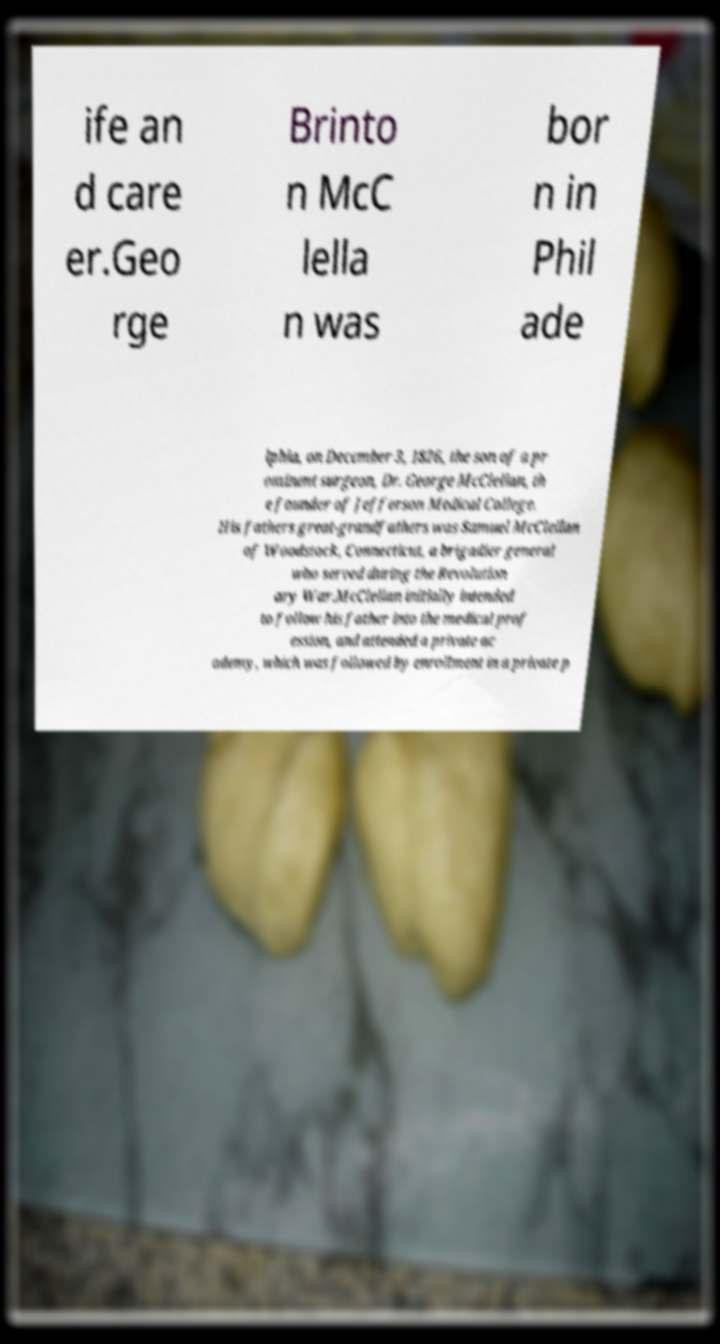For documentation purposes, I need the text within this image transcribed. Could you provide that? ife an d care er.Geo rge Brinto n McC lella n was bor n in Phil ade lphia, on December 3, 1826, the son of a pr ominent surgeon, Dr. George McClellan, th e founder of Jefferson Medical College. His fathers great-grandfathers was Samuel McClellan of Woodstock, Connecticut, a brigadier general who served during the Revolution ary War.McClellan initially intended to follow his father into the medical prof ession, and attended a private ac ademy, which was followed by enrollment in a private p 